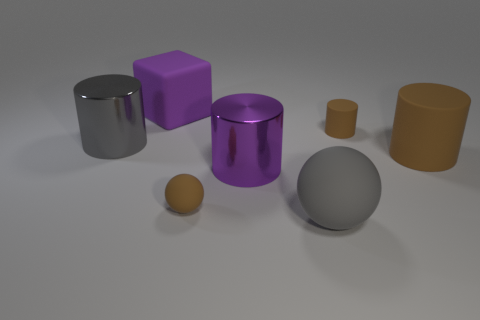Subtract all small brown matte cylinders. How many cylinders are left? 3 Subtract all brown cylinders. How many cylinders are left? 2 Subtract all brown balls. How many yellow cubes are left? 0 Add 1 large purple shiny objects. How many objects exist? 8 Subtract all cylinders. How many objects are left? 3 Subtract 1 blocks. How many blocks are left? 0 Subtract all red blocks. Subtract all gray balls. How many blocks are left? 1 Subtract all large brown matte objects. Subtract all big purple metal cylinders. How many objects are left? 5 Add 3 large purple matte objects. How many large purple matte objects are left? 4 Add 5 tiny brown rubber cylinders. How many tiny brown rubber cylinders exist? 6 